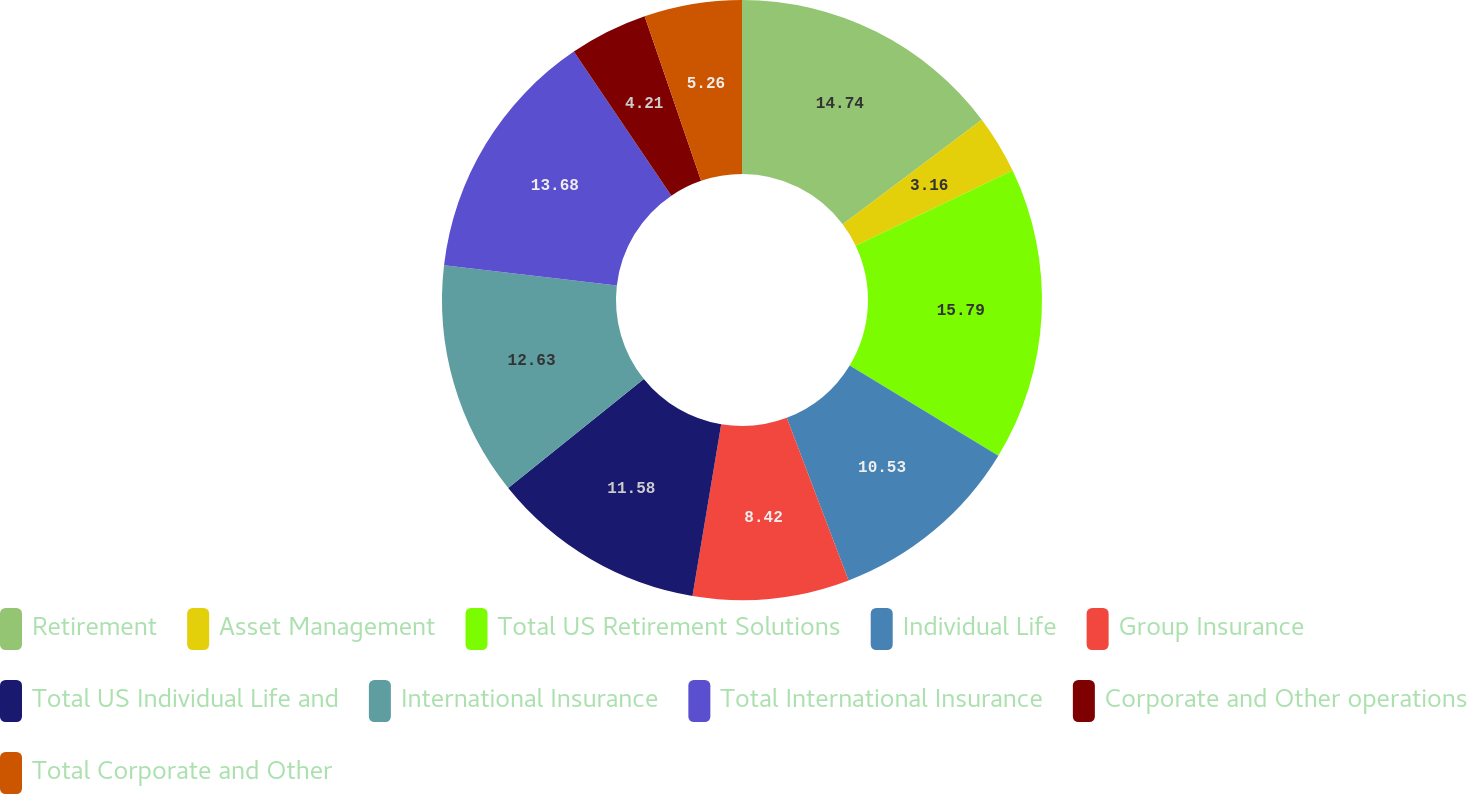<chart> <loc_0><loc_0><loc_500><loc_500><pie_chart><fcel>Retirement<fcel>Asset Management<fcel>Total US Retirement Solutions<fcel>Individual Life<fcel>Group Insurance<fcel>Total US Individual Life and<fcel>International Insurance<fcel>Total International Insurance<fcel>Corporate and Other operations<fcel>Total Corporate and Other<nl><fcel>14.74%<fcel>3.16%<fcel>15.79%<fcel>10.53%<fcel>8.42%<fcel>11.58%<fcel>12.63%<fcel>13.68%<fcel>4.21%<fcel>5.26%<nl></chart> 